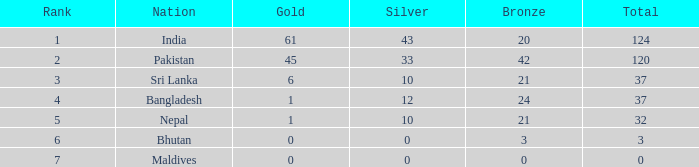What is the rank of a 21 bronze and a silver greater than 10? 0.0. 